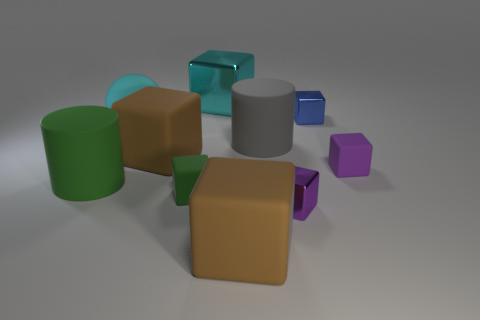Subtract 3 cubes. How many cubes are left? 4 Subtract all cyan cubes. How many cubes are left? 6 Subtract all brown cubes. How many cubes are left? 5 Subtract all yellow cubes. Subtract all yellow spheres. How many cubes are left? 7 Subtract all balls. How many objects are left? 9 Subtract 0 cyan cylinders. How many objects are left? 10 Subtract all cyan metallic cubes. Subtract all green cylinders. How many objects are left? 8 Add 2 tiny green rubber objects. How many tiny green rubber objects are left? 3 Add 7 large green matte blocks. How many large green matte blocks exist? 7 